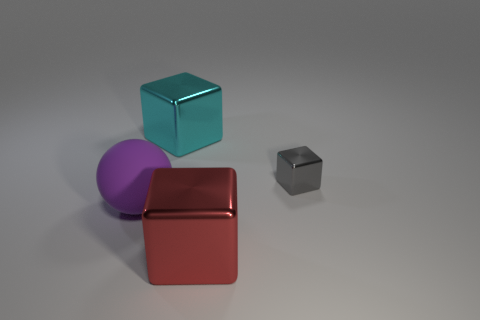Add 1 large cyan metal things. How many objects exist? 5 Subtract all blocks. How many objects are left? 1 Subtract 0 red cylinders. How many objects are left? 4 Subtract all cyan objects. Subtract all big green rubber blocks. How many objects are left? 3 Add 4 tiny metallic cubes. How many tiny metallic cubes are left? 5 Add 1 big rubber objects. How many big rubber objects exist? 2 